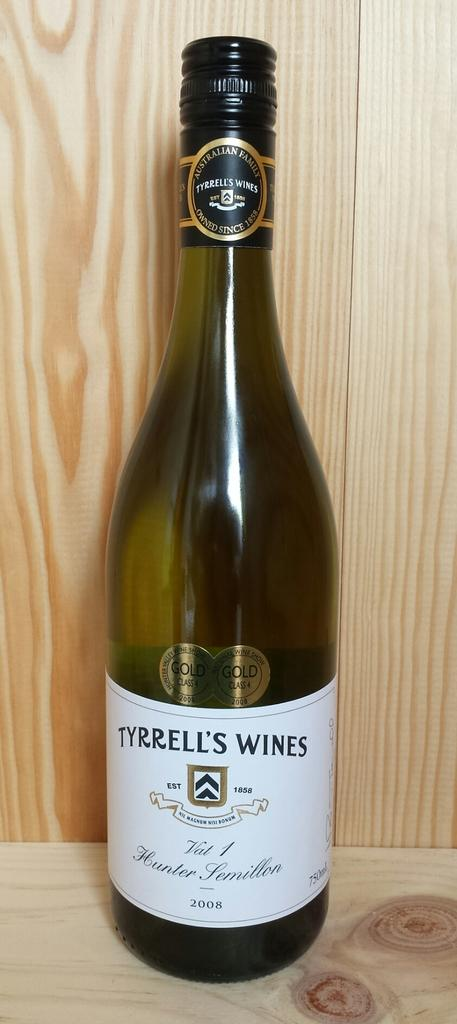What is the main object in the center of the image? There is a bottle in the center of the image. What type of wall can be seen in the background of the image? There is a wooden wall in the background of the image. What piece of furniture is at the bottom of the image? There is a table at the bottom of the image. How many celery stalks are being distributed on the table in the image? There is no celery present in the image, so it cannot be determined how many stalks might be distributed. 